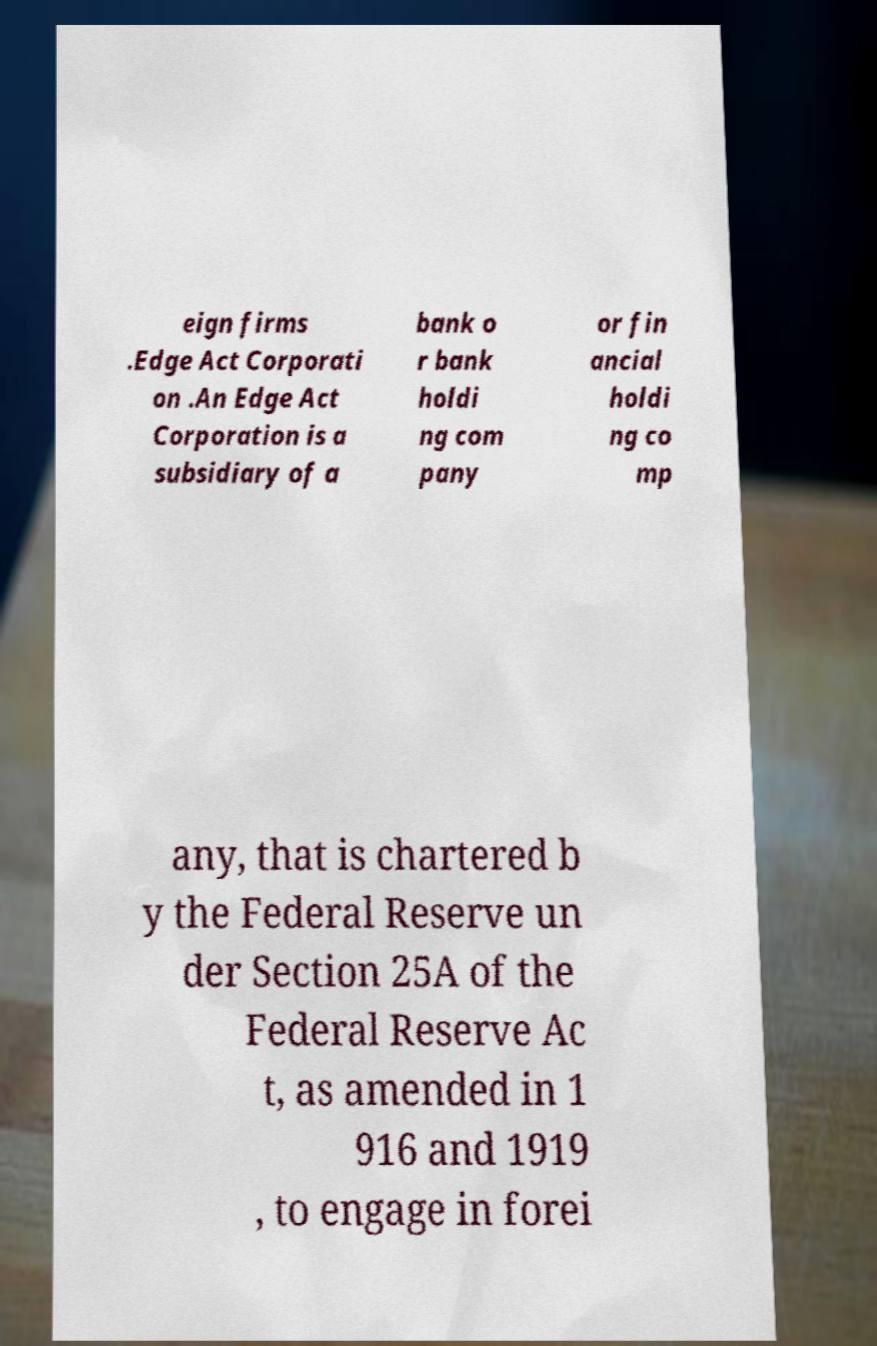Can you read and provide the text displayed in the image?This photo seems to have some interesting text. Can you extract and type it out for me? eign firms .Edge Act Corporati on .An Edge Act Corporation is a subsidiary of a bank o r bank holdi ng com pany or fin ancial holdi ng co mp any, that is chartered b y the Federal Reserve un der Section 25A of the Federal Reserve Ac t, as amended in 1 916 and 1919 , to engage in forei 